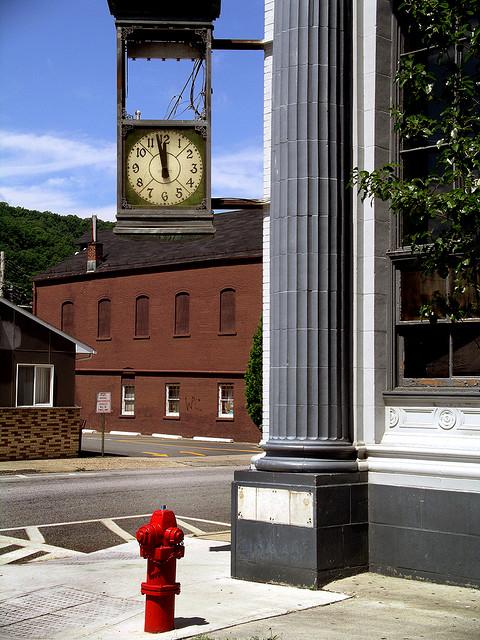Using a 24 hour time format, what time is it?
Keep it brief. 23:58. What does the clock work on?
Quick response, please. Electricity. What time is it?
Quick response, please. 11:58. Is it daytime or nighttime?
Keep it brief. Daytime. 